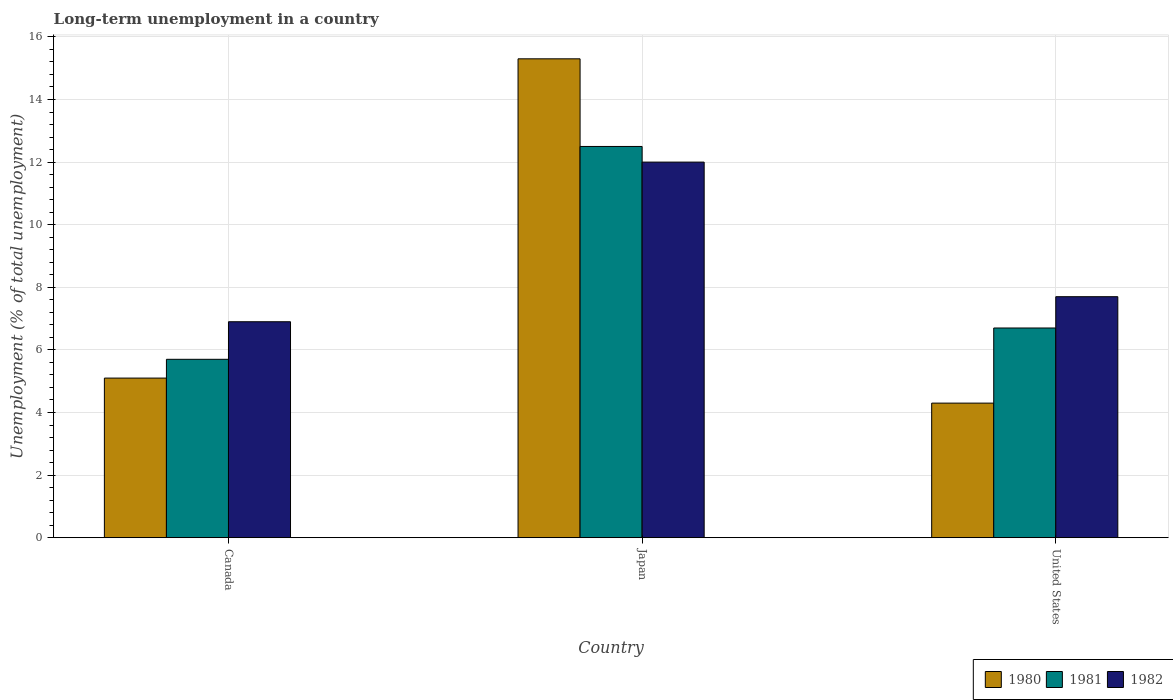How many groups of bars are there?
Your answer should be very brief. 3. Are the number of bars per tick equal to the number of legend labels?
Your response must be concise. Yes. Are the number of bars on each tick of the X-axis equal?
Make the answer very short. Yes. How many bars are there on the 3rd tick from the left?
Your answer should be very brief. 3. What is the label of the 2nd group of bars from the left?
Your answer should be very brief. Japan. In how many cases, is the number of bars for a given country not equal to the number of legend labels?
Make the answer very short. 0. What is the percentage of long-term unemployed population in 1980 in United States?
Offer a very short reply. 4.3. Across all countries, what is the maximum percentage of long-term unemployed population in 1981?
Give a very brief answer. 12.5. Across all countries, what is the minimum percentage of long-term unemployed population in 1982?
Give a very brief answer. 6.9. In which country was the percentage of long-term unemployed population in 1982 minimum?
Keep it short and to the point. Canada. What is the total percentage of long-term unemployed population in 1981 in the graph?
Provide a short and direct response. 24.9. What is the difference between the percentage of long-term unemployed population in 1980 in Japan and that in United States?
Ensure brevity in your answer.  11. What is the difference between the percentage of long-term unemployed population in 1981 in United States and the percentage of long-term unemployed population in 1982 in Japan?
Your response must be concise. -5.3. What is the average percentage of long-term unemployed population in 1981 per country?
Your answer should be compact. 8.3. What is the difference between the percentage of long-term unemployed population of/in 1981 and percentage of long-term unemployed population of/in 1980 in Japan?
Your answer should be very brief. -2.8. What is the ratio of the percentage of long-term unemployed population in 1981 in Canada to that in Japan?
Ensure brevity in your answer.  0.46. What is the difference between the highest and the second highest percentage of long-term unemployed population in 1982?
Provide a succinct answer. 5.1. What is the difference between the highest and the lowest percentage of long-term unemployed population in 1981?
Provide a succinct answer. 6.8. In how many countries, is the percentage of long-term unemployed population in 1981 greater than the average percentage of long-term unemployed population in 1981 taken over all countries?
Keep it short and to the point. 1. Is it the case that in every country, the sum of the percentage of long-term unemployed population in 1981 and percentage of long-term unemployed population in 1982 is greater than the percentage of long-term unemployed population in 1980?
Make the answer very short. Yes. How many bars are there?
Your answer should be very brief. 9. Are all the bars in the graph horizontal?
Make the answer very short. No. How many countries are there in the graph?
Keep it short and to the point. 3. Are the values on the major ticks of Y-axis written in scientific E-notation?
Provide a short and direct response. No. Where does the legend appear in the graph?
Offer a very short reply. Bottom right. How many legend labels are there?
Provide a succinct answer. 3. How are the legend labels stacked?
Offer a terse response. Horizontal. What is the title of the graph?
Your answer should be compact. Long-term unemployment in a country. What is the label or title of the Y-axis?
Your answer should be very brief. Unemployment (% of total unemployment). What is the Unemployment (% of total unemployment) in 1980 in Canada?
Make the answer very short. 5.1. What is the Unemployment (% of total unemployment) of 1981 in Canada?
Provide a short and direct response. 5.7. What is the Unemployment (% of total unemployment) of 1982 in Canada?
Your response must be concise. 6.9. What is the Unemployment (% of total unemployment) in 1980 in Japan?
Keep it short and to the point. 15.3. What is the Unemployment (% of total unemployment) in 1980 in United States?
Provide a succinct answer. 4.3. What is the Unemployment (% of total unemployment) of 1981 in United States?
Give a very brief answer. 6.7. What is the Unemployment (% of total unemployment) of 1982 in United States?
Your answer should be compact. 7.7. Across all countries, what is the maximum Unemployment (% of total unemployment) of 1980?
Provide a succinct answer. 15.3. Across all countries, what is the maximum Unemployment (% of total unemployment) of 1982?
Keep it short and to the point. 12. Across all countries, what is the minimum Unemployment (% of total unemployment) in 1980?
Provide a short and direct response. 4.3. Across all countries, what is the minimum Unemployment (% of total unemployment) of 1981?
Your answer should be compact. 5.7. Across all countries, what is the minimum Unemployment (% of total unemployment) of 1982?
Provide a succinct answer. 6.9. What is the total Unemployment (% of total unemployment) in 1980 in the graph?
Provide a succinct answer. 24.7. What is the total Unemployment (% of total unemployment) of 1981 in the graph?
Provide a succinct answer. 24.9. What is the total Unemployment (% of total unemployment) of 1982 in the graph?
Your answer should be very brief. 26.6. What is the difference between the Unemployment (% of total unemployment) of 1980 in Canada and that in Japan?
Make the answer very short. -10.2. What is the difference between the Unemployment (% of total unemployment) in 1981 in Canada and that in Japan?
Make the answer very short. -6.8. What is the difference between the Unemployment (% of total unemployment) of 1982 in Canada and that in United States?
Give a very brief answer. -0.8. What is the difference between the Unemployment (% of total unemployment) in 1982 in Japan and that in United States?
Make the answer very short. 4.3. What is the difference between the Unemployment (% of total unemployment) in 1980 in Canada and the Unemployment (% of total unemployment) in 1981 in Japan?
Your response must be concise. -7.4. What is the difference between the Unemployment (% of total unemployment) of 1981 in Canada and the Unemployment (% of total unemployment) of 1982 in Japan?
Provide a short and direct response. -6.3. What is the difference between the Unemployment (% of total unemployment) in 1980 in Canada and the Unemployment (% of total unemployment) in 1981 in United States?
Provide a short and direct response. -1.6. What is the difference between the Unemployment (% of total unemployment) of 1980 in Canada and the Unemployment (% of total unemployment) of 1982 in United States?
Your answer should be very brief. -2.6. What is the difference between the Unemployment (% of total unemployment) in 1980 in Japan and the Unemployment (% of total unemployment) in 1981 in United States?
Provide a succinct answer. 8.6. What is the difference between the Unemployment (% of total unemployment) in 1981 in Japan and the Unemployment (% of total unemployment) in 1982 in United States?
Your answer should be compact. 4.8. What is the average Unemployment (% of total unemployment) of 1980 per country?
Make the answer very short. 8.23. What is the average Unemployment (% of total unemployment) in 1982 per country?
Offer a very short reply. 8.87. What is the difference between the Unemployment (% of total unemployment) of 1980 and Unemployment (% of total unemployment) of 1981 in Canada?
Provide a succinct answer. -0.6. What is the difference between the Unemployment (% of total unemployment) in 1981 and Unemployment (% of total unemployment) in 1982 in Canada?
Your answer should be compact. -1.2. What is the difference between the Unemployment (% of total unemployment) in 1980 and Unemployment (% of total unemployment) in 1981 in Japan?
Ensure brevity in your answer.  2.8. What is the difference between the Unemployment (% of total unemployment) in 1980 and Unemployment (% of total unemployment) in 1982 in United States?
Give a very brief answer. -3.4. What is the ratio of the Unemployment (% of total unemployment) of 1981 in Canada to that in Japan?
Keep it short and to the point. 0.46. What is the ratio of the Unemployment (% of total unemployment) in 1982 in Canada to that in Japan?
Keep it short and to the point. 0.57. What is the ratio of the Unemployment (% of total unemployment) of 1980 in Canada to that in United States?
Keep it short and to the point. 1.19. What is the ratio of the Unemployment (% of total unemployment) of 1981 in Canada to that in United States?
Make the answer very short. 0.85. What is the ratio of the Unemployment (% of total unemployment) in 1982 in Canada to that in United States?
Give a very brief answer. 0.9. What is the ratio of the Unemployment (% of total unemployment) of 1980 in Japan to that in United States?
Your response must be concise. 3.56. What is the ratio of the Unemployment (% of total unemployment) of 1981 in Japan to that in United States?
Ensure brevity in your answer.  1.87. What is the ratio of the Unemployment (% of total unemployment) in 1982 in Japan to that in United States?
Your response must be concise. 1.56. What is the difference between the highest and the lowest Unemployment (% of total unemployment) of 1980?
Your response must be concise. 11. What is the difference between the highest and the lowest Unemployment (% of total unemployment) of 1981?
Offer a terse response. 6.8. What is the difference between the highest and the lowest Unemployment (% of total unemployment) in 1982?
Make the answer very short. 5.1. 